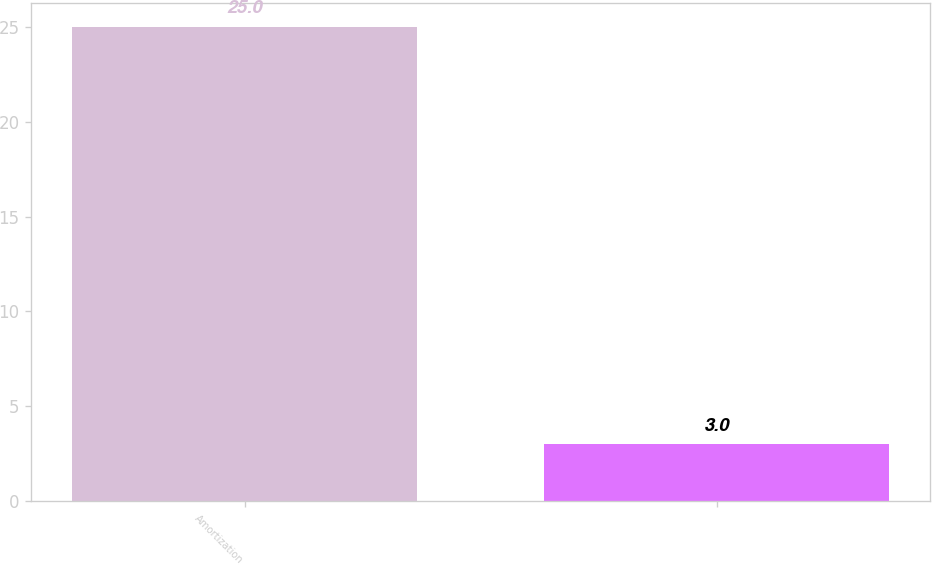Convert chart to OTSL. <chart><loc_0><loc_0><loc_500><loc_500><bar_chart><fcel>Amortization<fcel>Unnamed: 1<nl><fcel>25<fcel>3<nl></chart> 